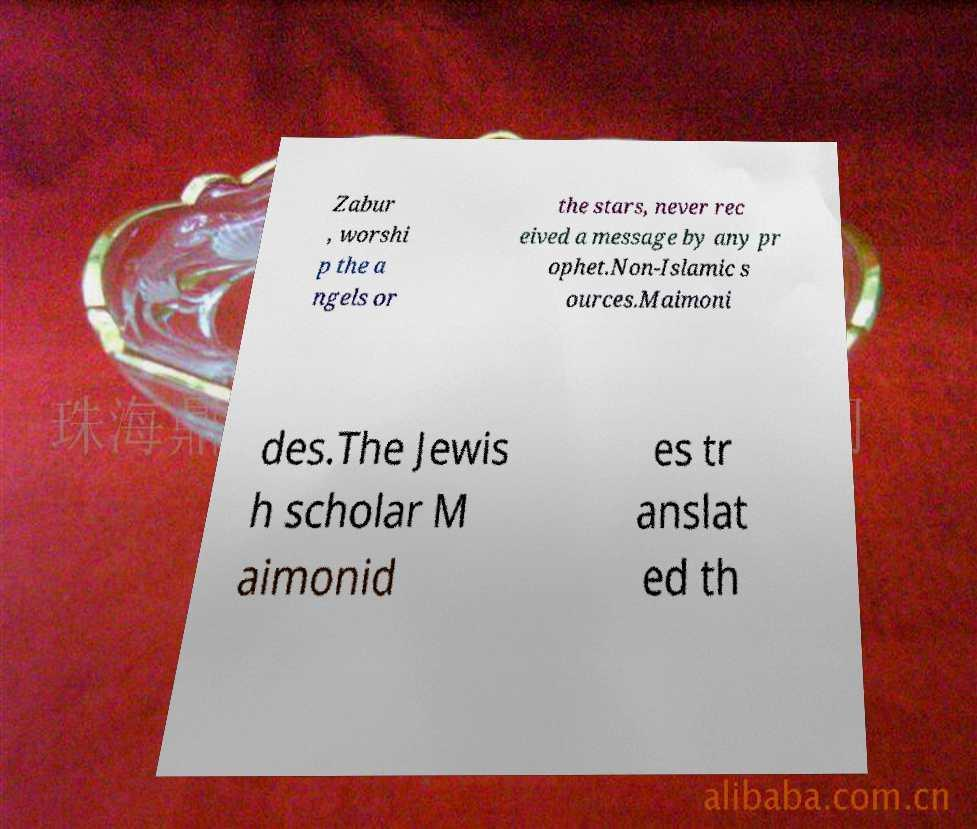Please identify and transcribe the text found in this image. Zabur , worshi p the a ngels or the stars, never rec eived a message by any pr ophet.Non-Islamic s ources.Maimoni des.The Jewis h scholar M aimonid es tr anslat ed th 